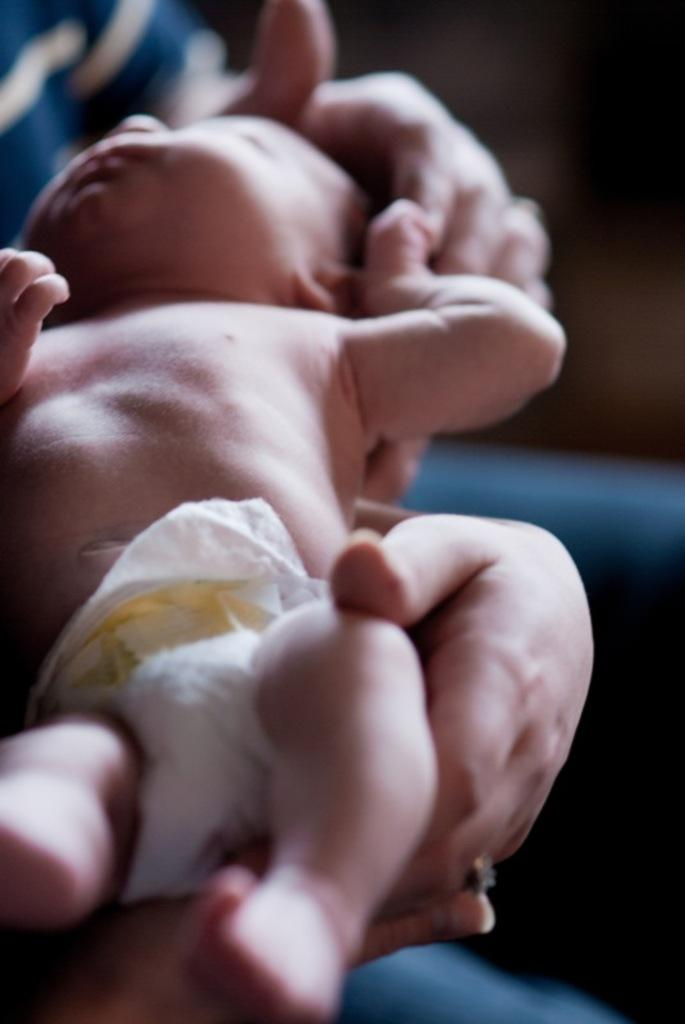What is the main subject of the image? There is a person in the image. What is the person doing in the image? The person is holding a baby with his hands. What type of invention can be seen in the background of the image? There is no invention present in the image; it only features a person holding a baby. How many girls are visible in the image? There are no girls present in the image. 